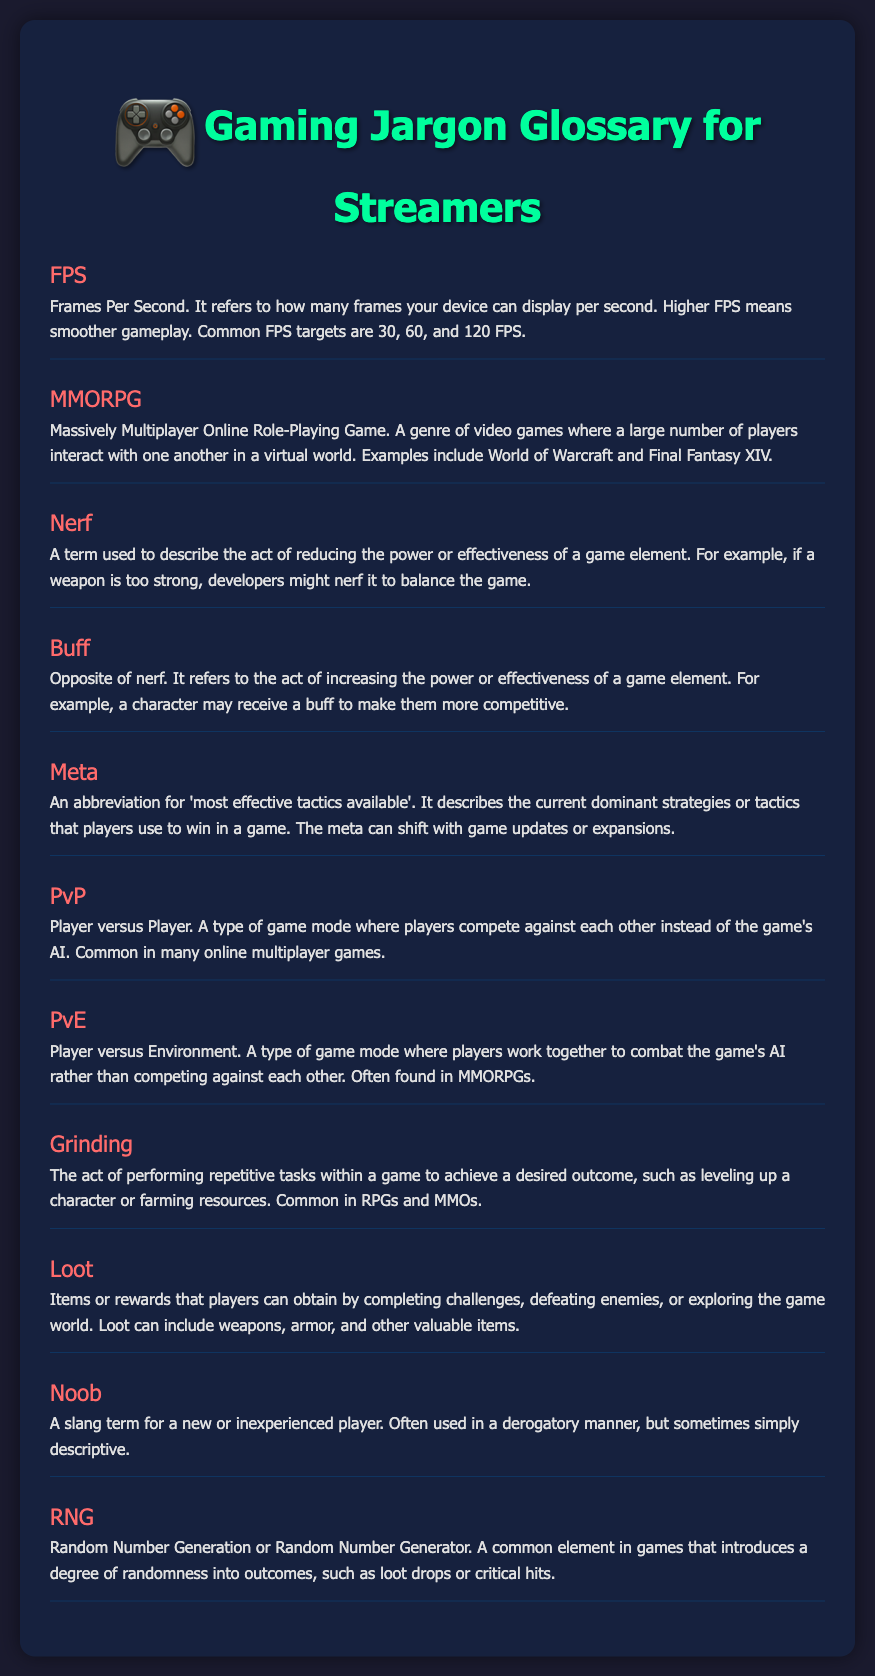What does FPS stand for? FPS is defined in the glossary as "Frames Per Second."
Answer: Frames Per Second What is the opposite of a nerf? The glossary specifies that the opposite of a nerf is a buff.
Answer: Buff What does MMORPG mean? The definition given in the document explains that MMORPG stands for "Massively Multiplayer Online Role-Playing Game."
Answer: Massively Multiplayer Online Role-Playing Game What type of game mode is PvE? According to the document, PvE stands for "Player versus Environment."
Answer: Player versus Environment What does the term "grinding" refer to in gaming? The glossary describes grinding as performing repetitive tasks within a game to achieve a desired outcome.
Answer: Repetitive tasks What is the purpose of loot in a game? The glossary states that loot refers to items or rewards obtained by completing challenges or defeating enemies.
Answer: Items or rewards What does RNG stand for? The document defines RNG as "Random Number Generation" or "Random Number Generator."
Answer: Random Number Generation What does the term "meta" refer to in gaming? The glossary explains that meta means "most effective tactics available."
Answer: Most effective tactics available In which genre would you commonly find grinding? The document indicates that grinding is common in RPGs and MMOs.
Answer: RPGs and MMOs 